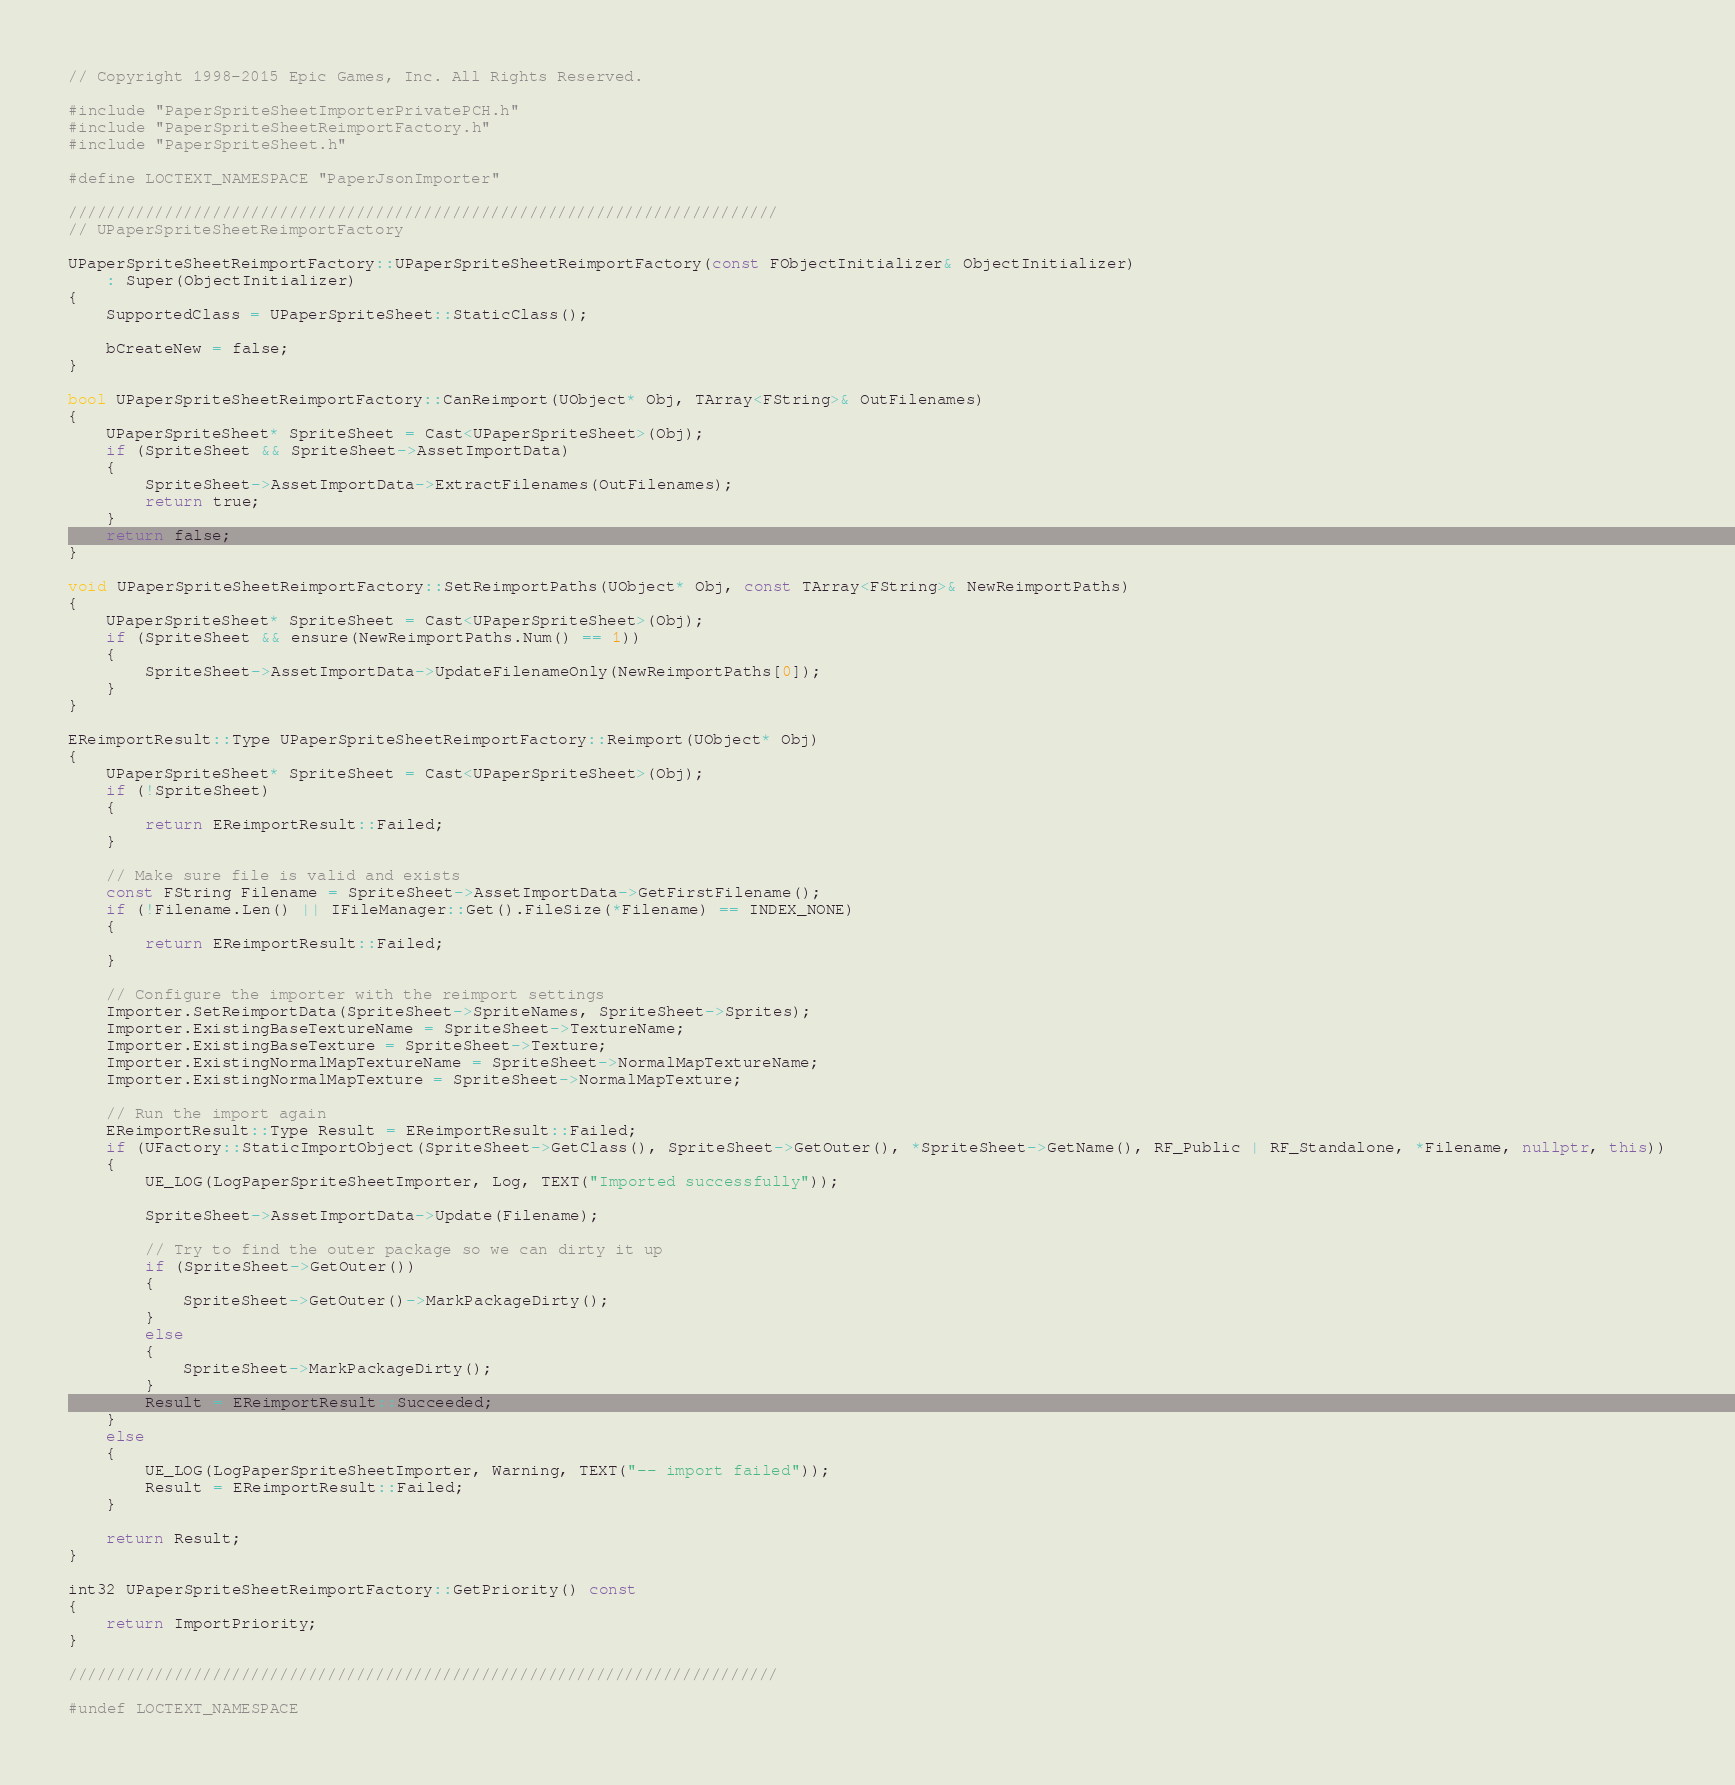Convert code to text. <code><loc_0><loc_0><loc_500><loc_500><_C++_>// Copyright 1998-2015 Epic Games, Inc. All Rights Reserved.

#include "PaperSpriteSheetImporterPrivatePCH.h"
#include "PaperSpriteSheetReimportFactory.h"
#include "PaperSpriteSheet.h"

#define LOCTEXT_NAMESPACE "PaperJsonImporter"

//////////////////////////////////////////////////////////////////////////
// UPaperSpriteSheetReimportFactory

UPaperSpriteSheetReimportFactory::UPaperSpriteSheetReimportFactory(const FObjectInitializer& ObjectInitializer)
	: Super(ObjectInitializer)
{
	SupportedClass = UPaperSpriteSheet::StaticClass();

	bCreateNew = false;
}

bool UPaperSpriteSheetReimportFactory::CanReimport(UObject* Obj, TArray<FString>& OutFilenames)
{
	UPaperSpriteSheet* SpriteSheet = Cast<UPaperSpriteSheet>(Obj);
	if (SpriteSheet && SpriteSheet->AssetImportData)
	{
		SpriteSheet->AssetImportData->ExtractFilenames(OutFilenames);
		return true;
	}
	return false;
}

void UPaperSpriteSheetReimportFactory::SetReimportPaths(UObject* Obj, const TArray<FString>& NewReimportPaths)
{
	UPaperSpriteSheet* SpriteSheet = Cast<UPaperSpriteSheet>(Obj);
	if (SpriteSheet && ensure(NewReimportPaths.Num() == 1))
	{
		SpriteSheet->AssetImportData->UpdateFilenameOnly(NewReimportPaths[0]);
	}
}

EReimportResult::Type UPaperSpriteSheetReimportFactory::Reimport(UObject* Obj)
{
	UPaperSpriteSheet* SpriteSheet = Cast<UPaperSpriteSheet>(Obj);
	if (!SpriteSheet)
	{
		return EReimportResult::Failed;
	}

	// Make sure file is valid and exists
	const FString Filename = SpriteSheet->AssetImportData->GetFirstFilename();
	if (!Filename.Len() || IFileManager::Get().FileSize(*Filename) == INDEX_NONE)
	{
		return EReimportResult::Failed;
	}

	// Configure the importer with the reimport settings
	Importer.SetReimportData(SpriteSheet->SpriteNames, SpriteSheet->Sprites);
	Importer.ExistingBaseTextureName = SpriteSheet->TextureName;
	Importer.ExistingBaseTexture = SpriteSheet->Texture;
	Importer.ExistingNormalMapTextureName = SpriteSheet->NormalMapTextureName;
	Importer.ExistingNormalMapTexture = SpriteSheet->NormalMapTexture;

	// Run the import again
	EReimportResult::Type Result = EReimportResult::Failed;
	if (UFactory::StaticImportObject(SpriteSheet->GetClass(), SpriteSheet->GetOuter(), *SpriteSheet->GetName(), RF_Public | RF_Standalone, *Filename, nullptr, this))
	{
		UE_LOG(LogPaperSpriteSheetImporter, Log, TEXT("Imported successfully"));

		SpriteSheet->AssetImportData->Update(Filename);
		
		// Try to find the outer package so we can dirty it up
		if (SpriteSheet->GetOuter())
		{
			SpriteSheet->GetOuter()->MarkPackageDirty();
		}
		else
		{
			SpriteSheet->MarkPackageDirty();
		}
		Result = EReimportResult::Succeeded;
	}
	else
	{
		UE_LOG(LogPaperSpriteSheetImporter, Warning, TEXT("-- import failed"));
		Result = EReimportResult::Failed;
	}

	return Result;
}

int32 UPaperSpriteSheetReimportFactory::GetPriority() const
{
	return ImportPriority;
}

//////////////////////////////////////////////////////////////////////////

#undef LOCTEXT_NAMESPACE
</code> 